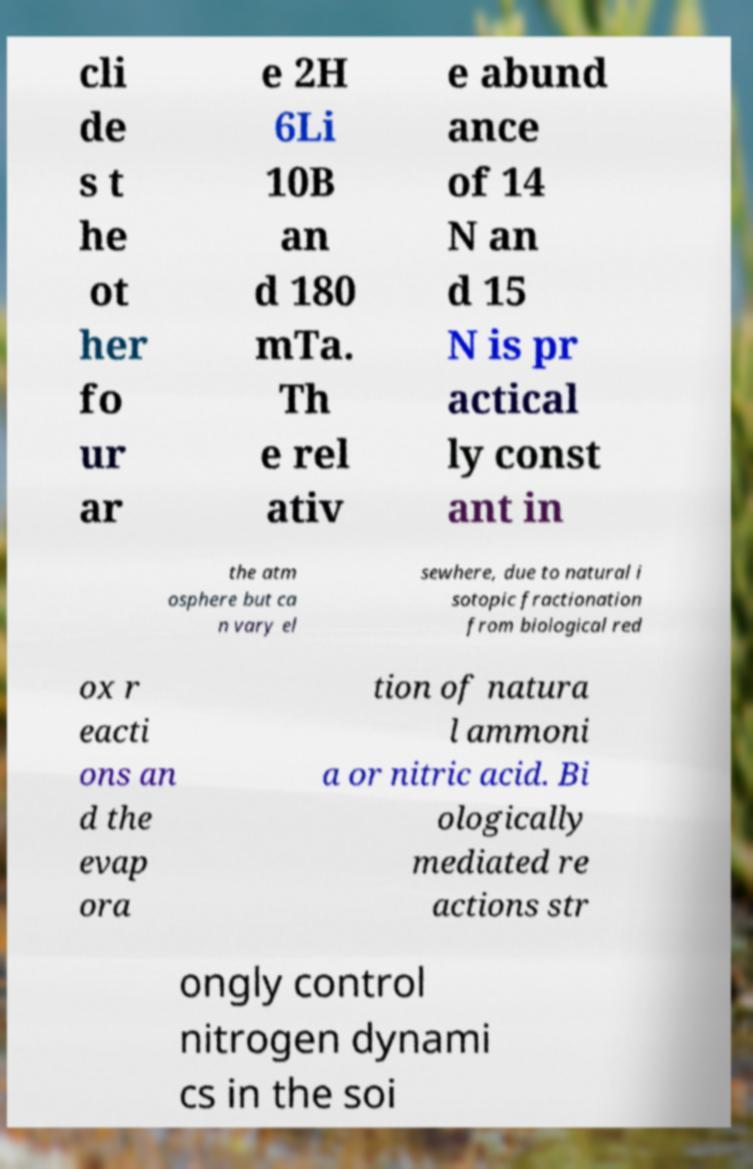I need the written content from this picture converted into text. Can you do that? cli de s t he ot her fo ur ar e 2H 6Li 10B an d 180 mTa. Th e rel ativ e abund ance of 14 N an d 15 N is pr actical ly const ant in the atm osphere but ca n vary el sewhere, due to natural i sotopic fractionation from biological red ox r eacti ons an d the evap ora tion of natura l ammoni a or nitric acid. Bi ologically mediated re actions str ongly control nitrogen dynami cs in the soi 